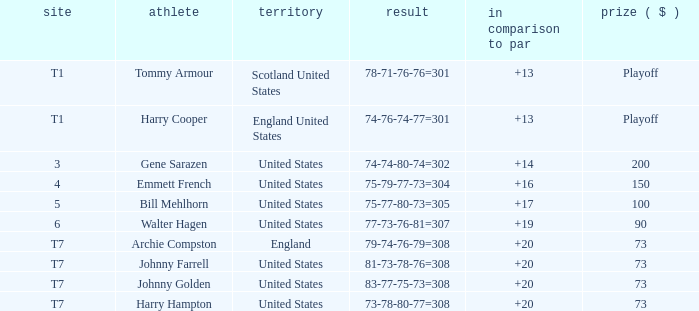Which country has a to par less than 19 and a score of 75-79-77-73=304? United States. 